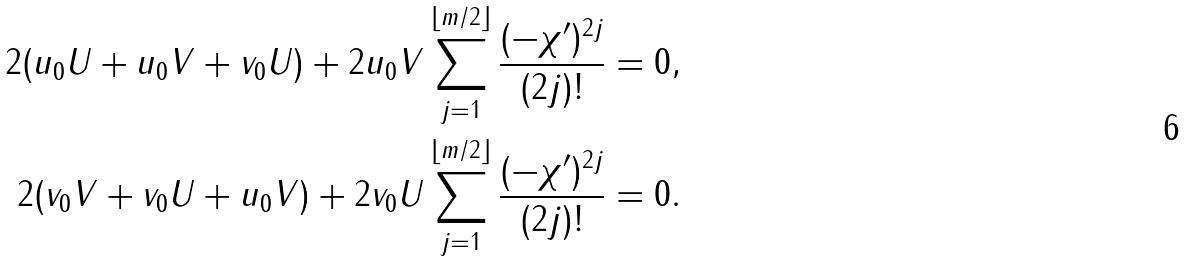Convert formula to latex. <formula><loc_0><loc_0><loc_500><loc_500>2 ( u _ { 0 } U + u _ { 0 } V + v _ { 0 } U ) + 2 u _ { 0 } V \sum _ { j = 1 } ^ { \lfloor m / 2 \rfloor } \frac { ( - \chi ^ { \prime } ) ^ { 2 j } } { ( 2 j ) ! } & = 0 , \\ 2 ( v _ { 0 } V + v _ { 0 } U + u _ { 0 } V ) + 2 v _ { 0 } U \sum _ { j = 1 } ^ { \lfloor m / 2 \rfloor } \frac { ( - \chi ^ { \prime } ) ^ { 2 j } } { ( 2 j ) ! } & = 0 .</formula> 